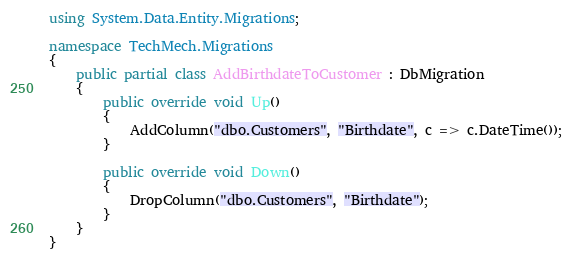Convert code to text. <code><loc_0><loc_0><loc_500><loc_500><_C#_>using System.Data.Entity.Migrations;

namespace TechMech.Migrations
{
    public partial class AddBirthdateToCustomer : DbMigration
    {
        public override void Up()
        {
            AddColumn("dbo.Customers", "Birthdate", c => c.DateTime());
        }
        
        public override void Down()
        {
            DropColumn("dbo.Customers", "Birthdate");
        }
    }
}
</code> 